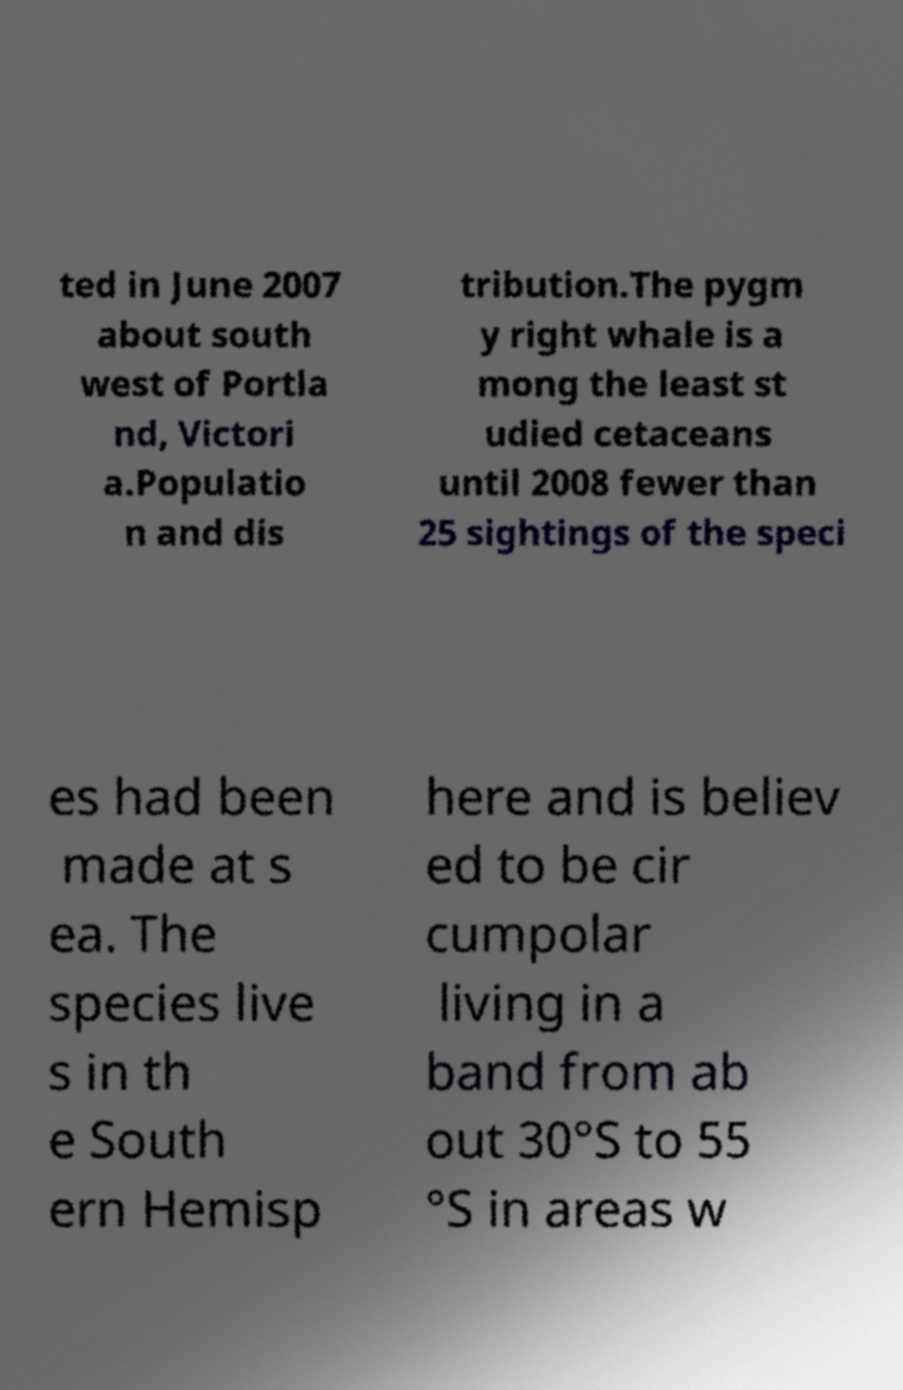Can you read and provide the text displayed in the image?This photo seems to have some interesting text. Can you extract and type it out for me? ted in June 2007 about south west of Portla nd, Victori a.Populatio n and dis tribution.The pygm y right whale is a mong the least st udied cetaceans until 2008 fewer than 25 sightings of the speci es had been made at s ea. The species live s in th e South ern Hemisp here and is believ ed to be cir cumpolar living in a band from ab out 30°S to 55 °S in areas w 